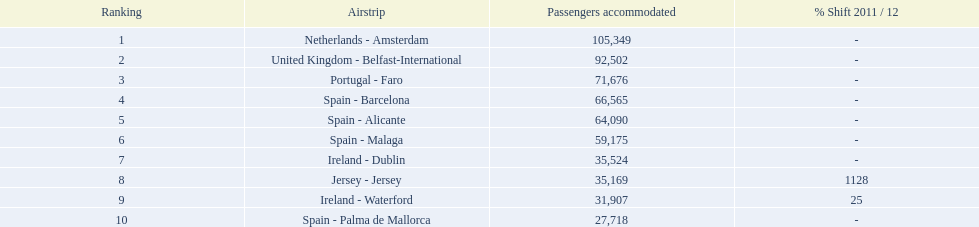What are all the airports in the top 10 busiest routes to and from london southend airport? Netherlands - Amsterdam, United Kingdom - Belfast-International, Portugal - Faro, Spain - Barcelona, Spain - Alicante, Spain - Malaga, Ireland - Dublin, Jersey - Jersey, Ireland - Waterford, Spain - Palma de Mallorca. Which airports are in portugal? Portugal - Faro. 